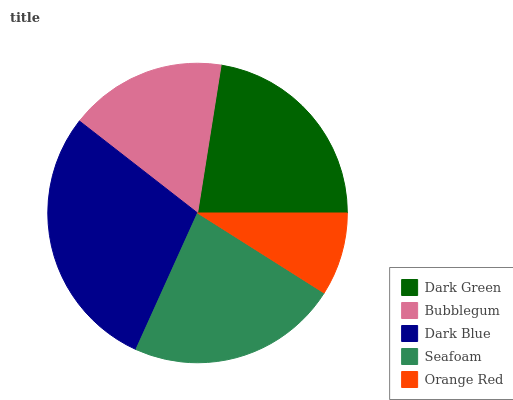Is Orange Red the minimum?
Answer yes or no. Yes. Is Dark Blue the maximum?
Answer yes or no. Yes. Is Bubblegum the minimum?
Answer yes or no. No. Is Bubblegum the maximum?
Answer yes or no. No. Is Dark Green greater than Bubblegum?
Answer yes or no. Yes. Is Bubblegum less than Dark Green?
Answer yes or no. Yes. Is Bubblegum greater than Dark Green?
Answer yes or no. No. Is Dark Green less than Bubblegum?
Answer yes or no. No. Is Dark Green the high median?
Answer yes or no. Yes. Is Dark Green the low median?
Answer yes or no. Yes. Is Orange Red the high median?
Answer yes or no. No. Is Dark Blue the low median?
Answer yes or no. No. 